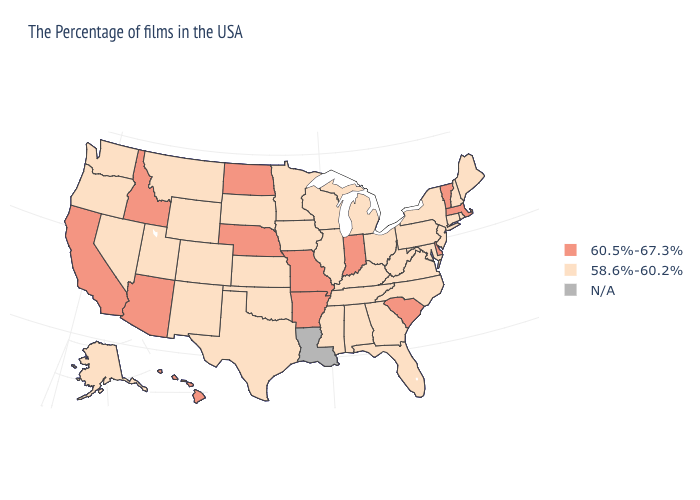What is the lowest value in states that border Nevada?
Keep it brief. 58.6%-60.2%. What is the value of California?
Quick response, please. 60.5%-67.3%. What is the value of Delaware?
Be succinct. 60.5%-67.3%. Does Vermont have the highest value in the Northeast?
Answer briefly. Yes. What is the value of West Virginia?
Answer briefly. 58.6%-60.2%. Which states have the highest value in the USA?
Concise answer only. Massachusetts, Vermont, Delaware, South Carolina, Indiana, Missouri, Arkansas, Nebraska, North Dakota, Arizona, Idaho, California, Hawaii. Does Oklahoma have the lowest value in the USA?
Answer briefly. Yes. Does the map have missing data?
Quick response, please. Yes. Among the states that border New Jersey , which have the lowest value?
Answer briefly. New York, Pennsylvania. Name the states that have a value in the range 58.6%-60.2%?
Write a very short answer. Maine, Rhode Island, New Hampshire, Connecticut, New York, New Jersey, Maryland, Pennsylvania, Virginia, North Carolina, West Virginia, Ohio, Florida, Georgia, Michigan, Kentucky, Alabama, Tennessee, Wisconsin, Illinois, Mississippi, Minnesota, Iowa, Kansas, Oklahoma, Texas, South Dakota, Wyoming, Colorado, New Mexico, Utah, Montana, Nevada, Washington, Oregon, Alaska. What is the value of Kentucky?
Short answer required. 58.6%-60.2%. What is the highest value in the South ?
Short answer required. 60.5%-67.3%. Name the states that have a value in the range 60.5%-67.3%?
Be succinct. Massachusetts, Vermont, Delaware, South Carolina, Indiana, Missouri, Arkansas, Nebraska, North Dakota, Arizona, Idaho, California, Hawaii. What is the value of Montana?
Keep it brief. 58.6%-60.2%. Name the states that have a value in the range 58.6%-60.2%?
Answer briefly. Maine, Rhode Island, New Hampshire, Connecticut, New York, New Jersey, Maryland, Pennsylvania, Virginia, North Carolina, West Virginia, Ohio, Florida, Georgia, Michigan, Kentucky, Alabama, Tennessee, Wisconsin, Illinois, Mississippi, Minnesota, Iowa, Kansas, Oklahoma, Texas, South Dakota, Wyoming, Colorado, New Mexico, Utah, Montana, Nevada, Washington, Oregon, Alaska. 